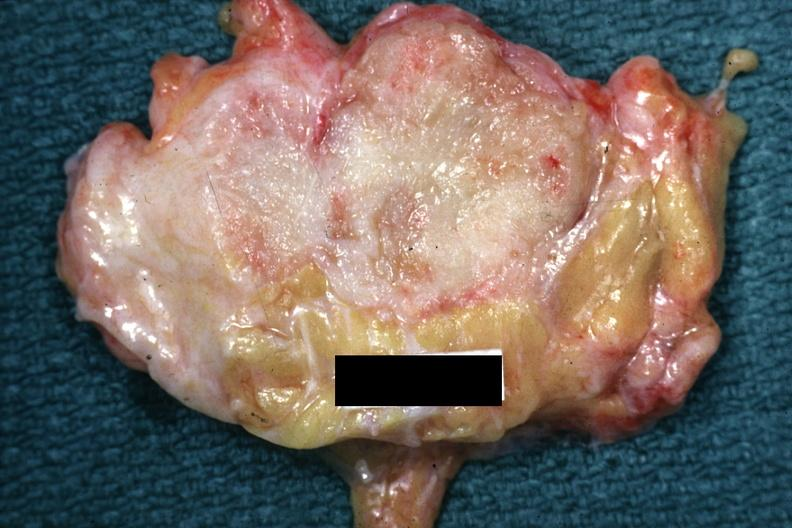what appears too small for this?
Answer the question using a single word or phrase. Lesion 